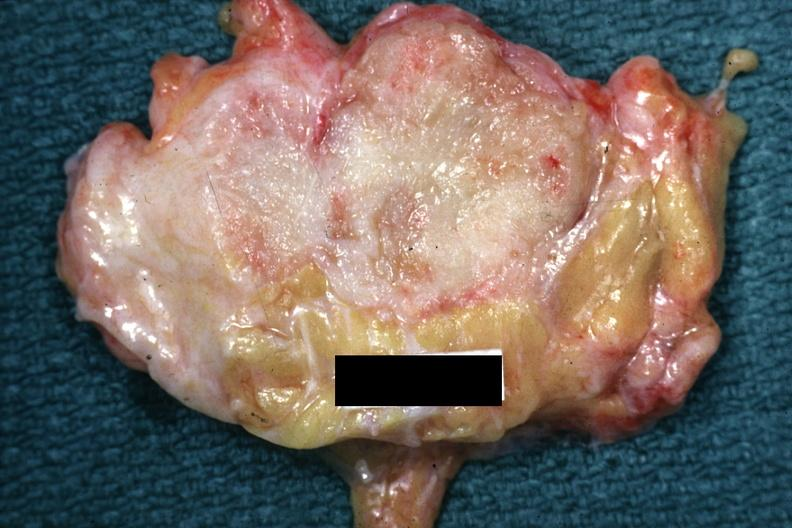what appears too small for this?
Answer the question using a single word or phrase. Lesion 